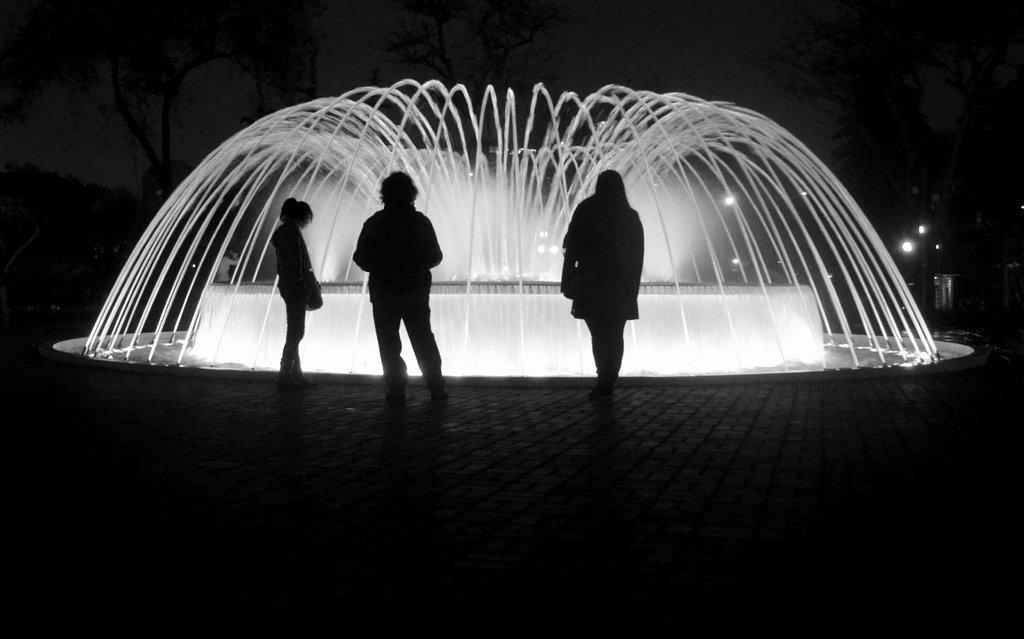What is happening in the center of the image? There are three persons on the floor in the center of the image. What can be seen in the image besides the people on the floor? There is a fountain in the image. What is visible in the background of the image? There are trees and the sky visible in the background of the image. What type of bear can be seen in the image? There is no bear present in the image. How does the fountain lift the water in the image? The fountain does not lift the water in the image; it is a static object. 